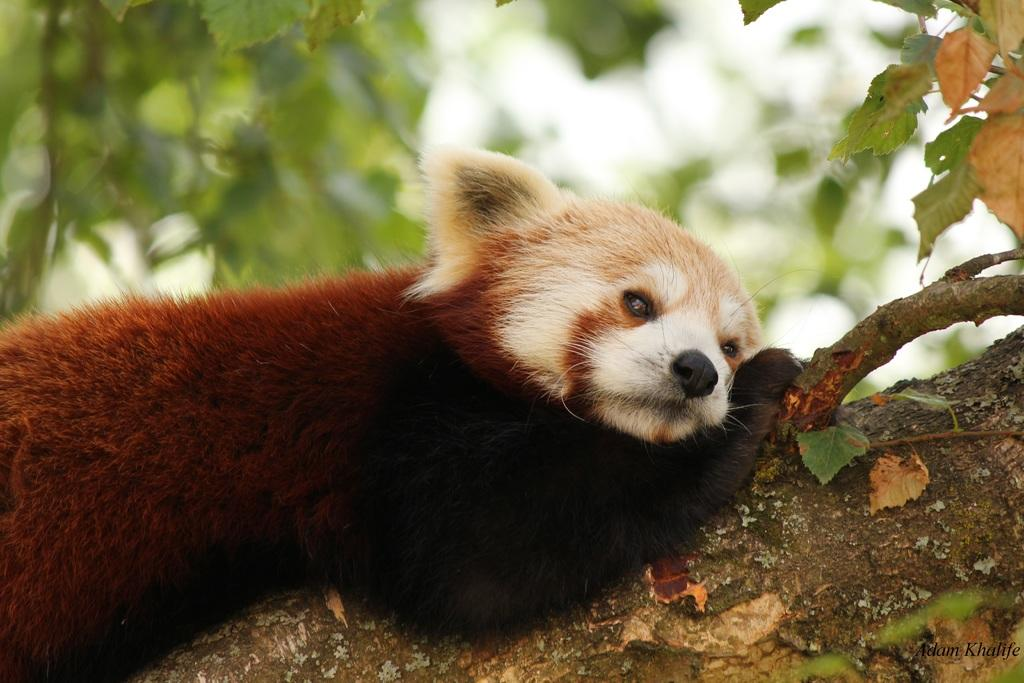What type of animal is in the image? There is a red panda in the image. Where is the red panda located? The red panda is lying on a branch of a tree. Is there any text present in the image? Yes, there is some text at the bottom of the image. What invention is the red panda using to grip the branch in the image? The red panda is not using any invention to grip the branch; it is a natural ability of the animal. 